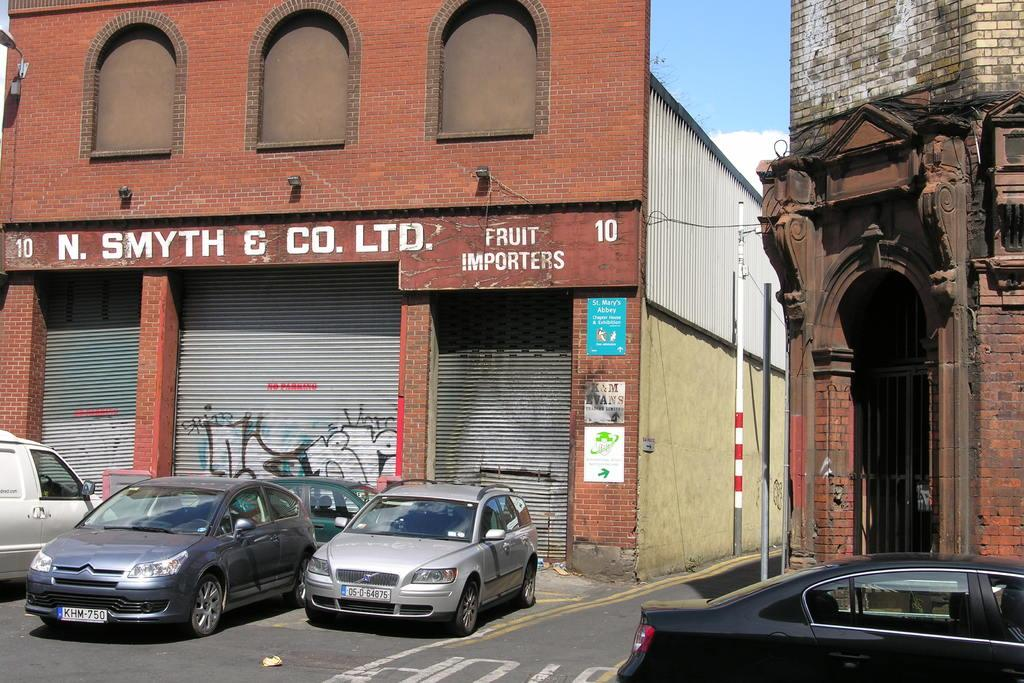What type of vehicles can be seen on the road in the image? There are cars on the road in the image. What structures can be seen in the background of the image? There are buildings in the background of the image. What part of the natural environment is visible in the image? The sky is visible in the background of the image. Can you see any cracks in the road where the cars are driving? There is no mention of cracks in the road in the image, so it cannot be determined if any are present. 